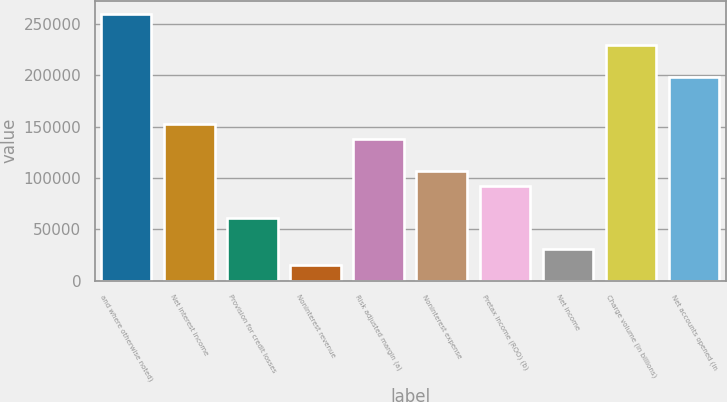Convert chart to OTSL. <chart><loc_0><loc_0><loc_500><loc_500><bar_chart><fcel>and where otherwise noted)<fcel>Net interest income<fcel>Provision for credit losses<fcel>Noninterest revenue<fcel>Risk adjusted margin (a)<fcel>Noninterest expense<fcel>Pretax income (ROO) (b)<fcel>Net income<fcel>Charge volume (in billions)<fcel>Net accounts opened (in<nl><fcel>259812<fcel>152831<fcel>61133.3<fcel>15284.5<fcel>137548<fcel>106982<fcel>91699.2<fcel>30567.4<fcel>229246<fcel>198680<nl></chart> 